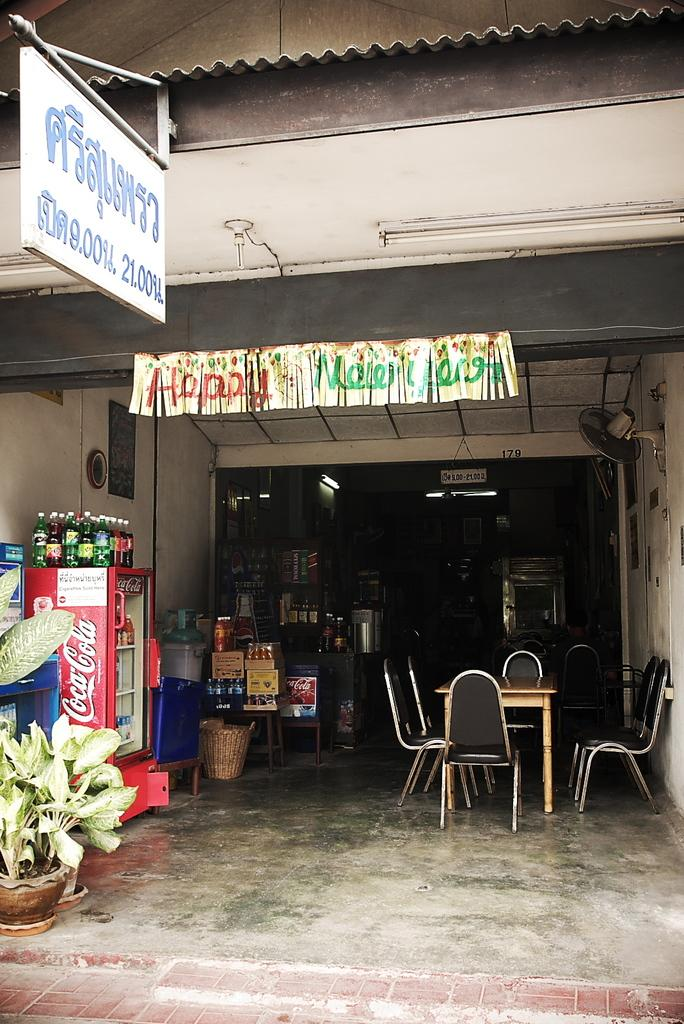What type of establishment is depicted in the image? There is a shop in the image. What can be seen hanging outside the shop? There is a banner in the image. What items can be found inside the shop? There are items inside the shop. What furniture is present in the image? There is a table and chairs in the image. Where are the bottles, fridge, and plants located in the image? They are all present on the left side of the image. What type of insurance policy is being advertised on the banner in the image? There is no mention of insurance in the image; the banner is not advertising any insurance policy. Can you describe the stranger sitting at the table in the image? There is no stranger present in the image; only the table and chairs are visible. 